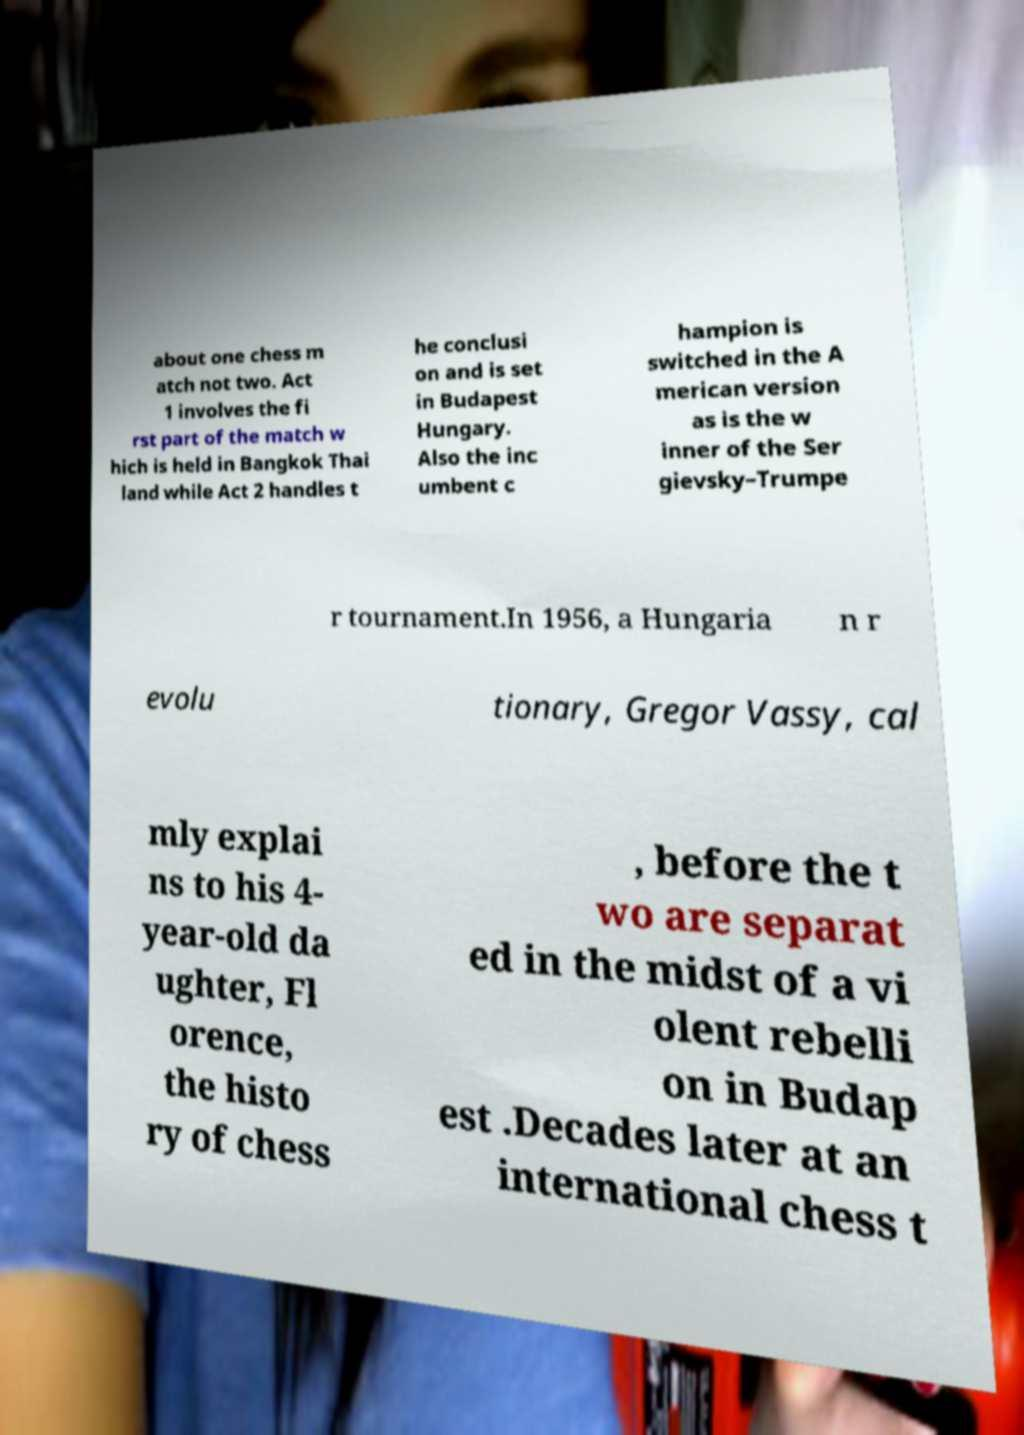I need the written content from this picture converted into text. Can you do that? about one chess m atch not two. Act 1 involves the fi rst part of the match w hich is held in Bangkok Thai land while Act 2 handles t he conclusi on and is set in Budapest Hungary. Also the inc umbent c hampion is switched in the A merican version as is the w inner of the Ser gievsky–Trumpe r tournament.In 1956, a Hungaria n r evolu tionary, Gregor Vassy, cal mly explai ns to his 4- year-old da ughter, Fl orence, the histo ry of chess , before the t wo are separat ed in the midst of a vi olent rebelli on in Budap est .Decades later at an international chess t 